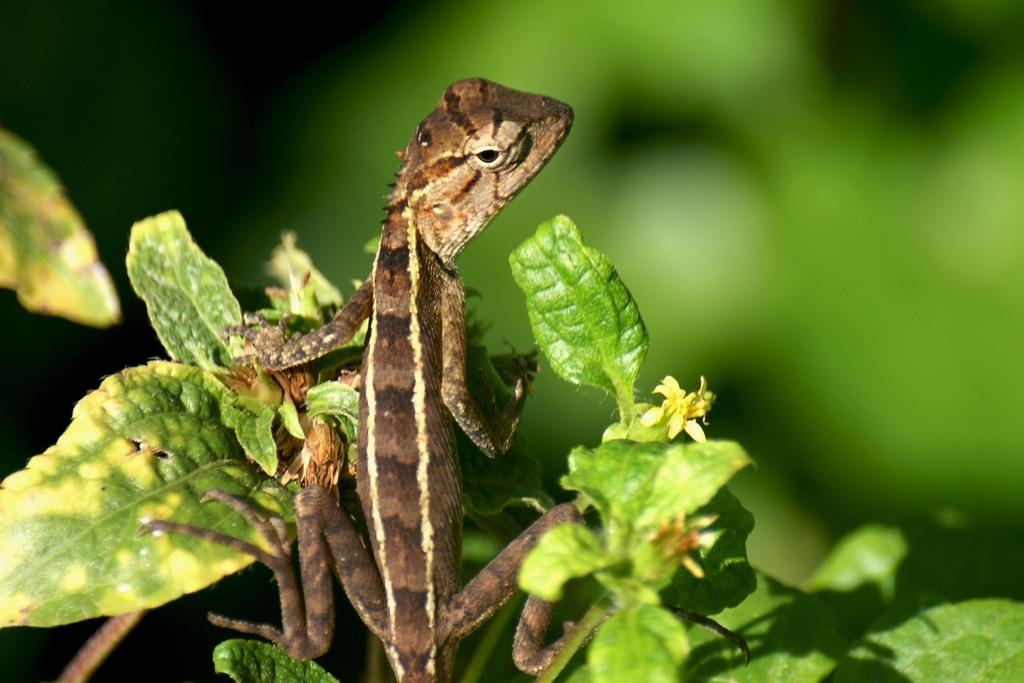What type of animal is in the image? There is a reptile in the image. What is the reptile resting on? The reptile is on leaves. What color is predominant in the background of the image? The background of the image is green. What type of pancake is being served on the plate in the image? There is no plate or pancake present in the image; it features a reptile on leaves with a green background. 